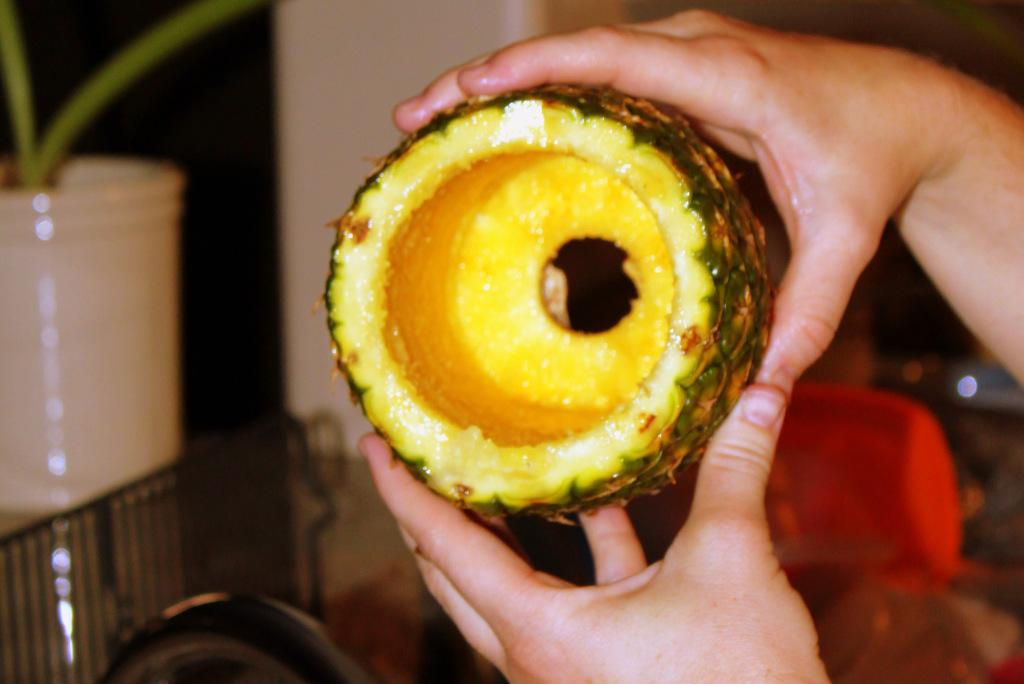What is the person in the image holding? The person is holding a pineapple in the image. What else can be seen on the left side of the image? There is a small plant on the left side of the image. What type of fruit is the person holding in the image? The person is holding a pineapple, which is a fruit, in the image. Can you see a crow in the image? There is no crow present in the image. 